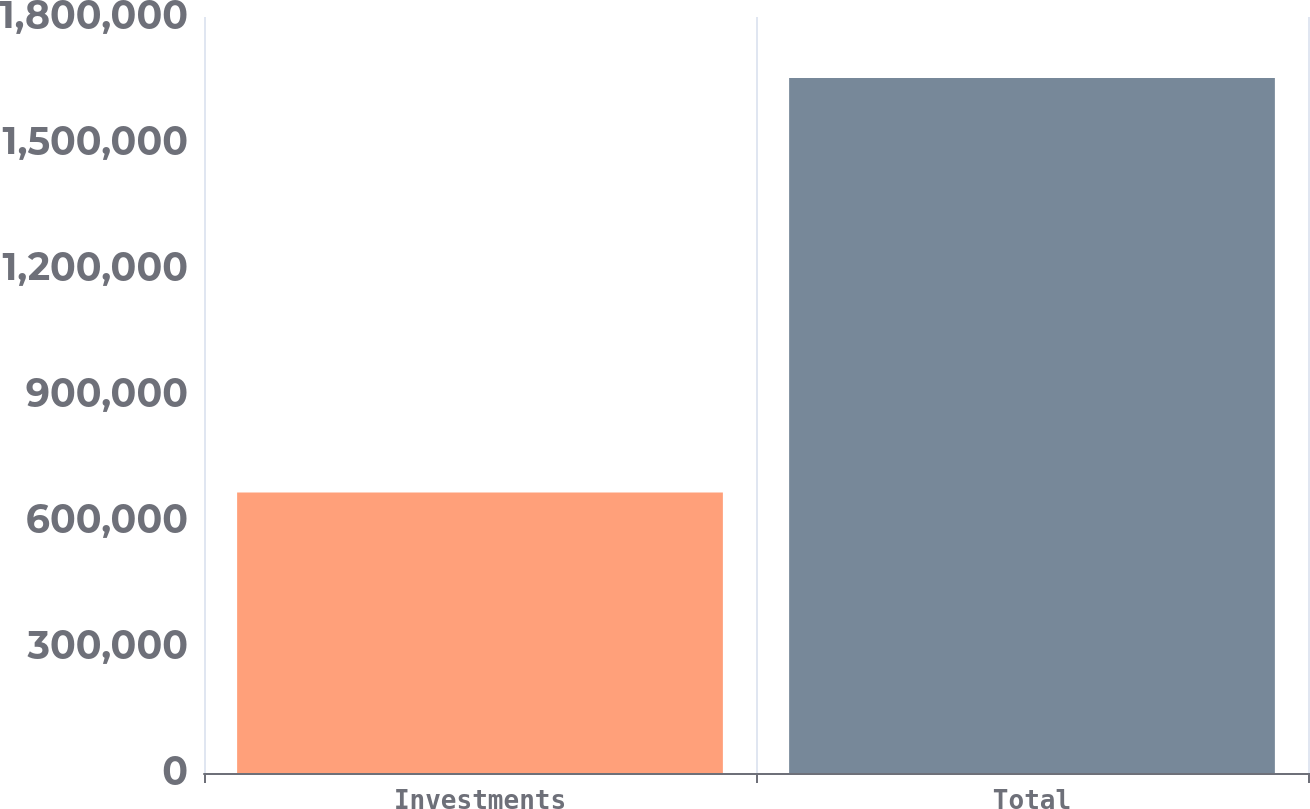Convert chart. <chart><loc_0><loc_0><loc_500><loc_500><bar_chart><fcel>Investments<fcel>Total<nl><fcel>668118<fcel>1.65479e+06<nl></chart> 